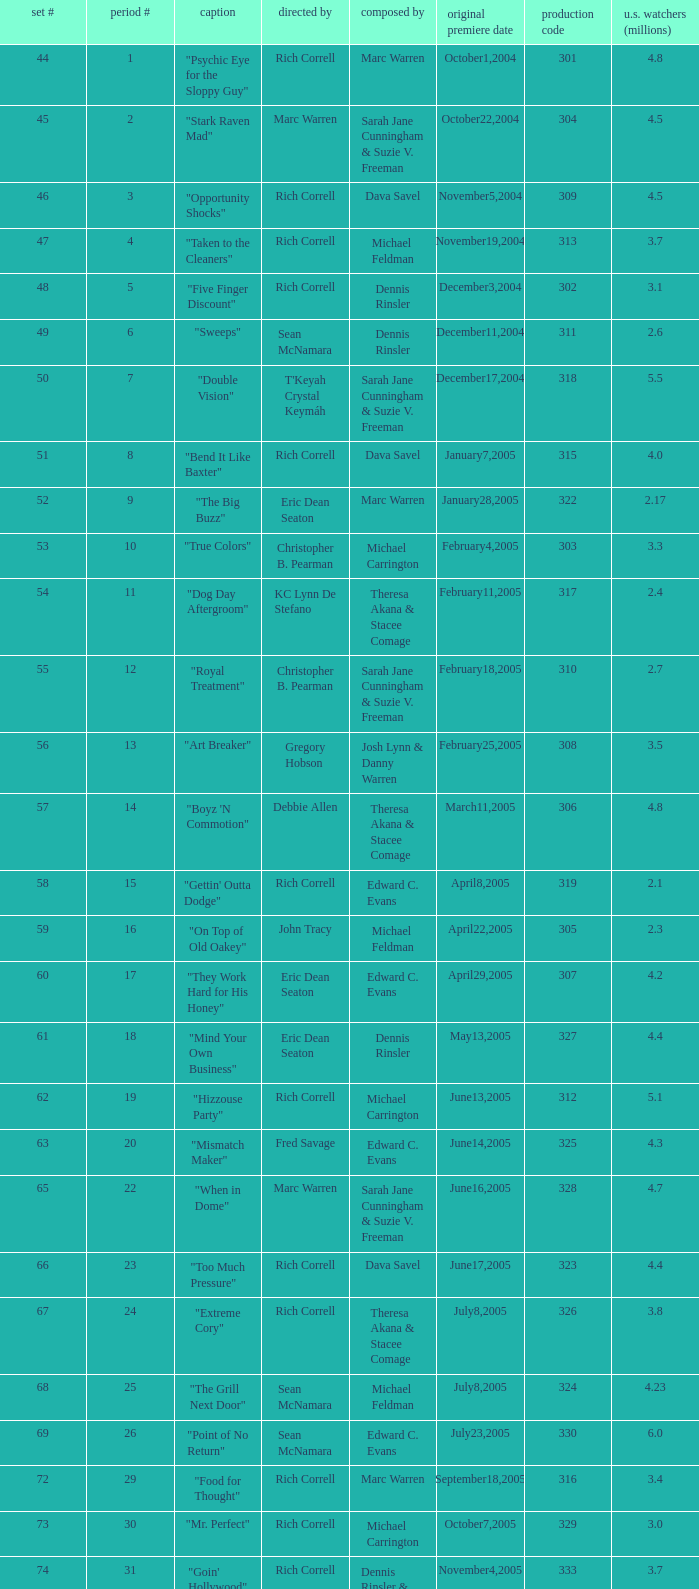What is the title of the episode directed by Rich Correll and written by Dennis Rinsler? "Five Finger Discount". 